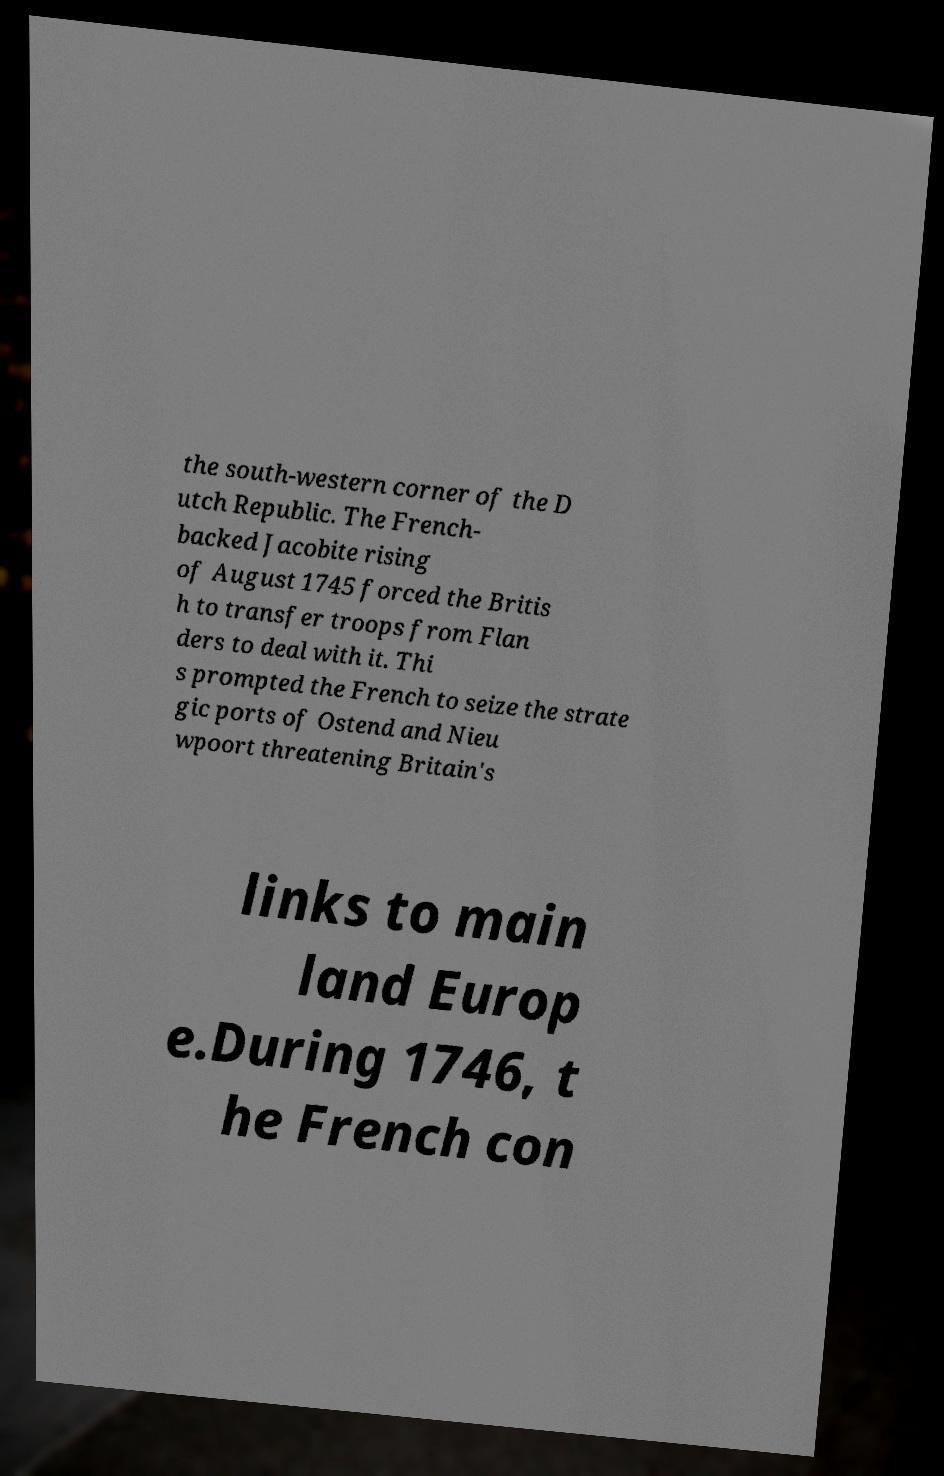There's text embedded in this image that I need extracted. Can you transcribe it verbatim? the south-western corner of the D utch Republic. The French- backed Jacobite rising of August 1745 forced the Britis h to transfer troops from Flan ders to deal with it. Thi s prompted the French to seize the strate gic ports of Ostend and Nieu wpoort threatening Britain's links to main land Europ e.During 1746, t he French con 